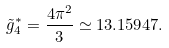Convert formula to latex. <formula><loc_0><loc_0><loc_500><loc_500>\tilde { g } _ { 4 } ^ { * } = \frac { 4 \pi ^ { 2 } } { 3 } \simeq 1 3 . 1 5 9 4 7 .</formula> 